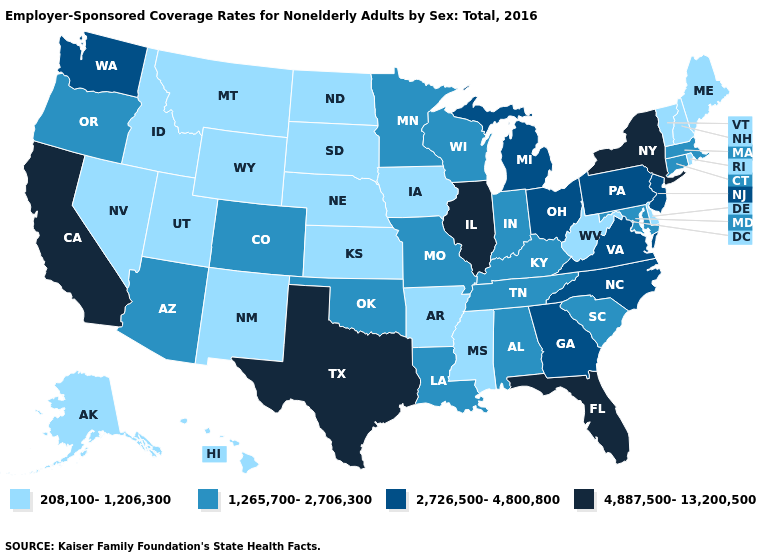What is the value of Colorado?
Quick response, please. 1,265,700-2,706,300. Name the states that have a value in the range 4,887,500-13,200,500?
Give a very brief answer. California, Florida, Illinois, New York, Texas. What is the value of Pennsylvania?
Answer briefly. 2,726,500-4,800,800. What is the value of Wyoming?
Concise answer only. 208,100-1,206,300. Name the states that have a value in the range 208,100-1,206,300?
Short answer required. Alaska, Arkansas, Delaware, Hawaii, Idaho, Iowa, Kansas, Maine, Mississippi, Montana, Nebraska, Nevada, New Hampshire, New Mexico, North Dakota, Rhode Island, South Dakota, Utah, Vermont, West Virginia, Wyoming. Which states hav the highest value in the MidWest?
Answer briefly. Illinois. What is the highest value in the West ?
Short answer required. 4,887,500-13,200,500. What is the value of New Hampshire?
Write a very short answer. 208,100-1,206,300. What is the value of Arizona?
Concise answer only. 1,265,700-2,706,300. What is the value of Maryland?
Keep it brief. 1,265,700-2,706,300. Does West Virginia have the lowest value in the South?
Give a very brief answer. Yes. Name the states that have a value in the range 208,100-1,206,300?
Short answer required. Alaska, Arkansas, Delaware, Hawaii, Idaho, Iowa, Kansas, Maine, Mississippi, Montana, Nebraska, Nevada, New Hampshire, New Mexico, North Dakota, Rhode Island, South Dakota, Utah, Vermont, West Virginia, Wyoming. Does Louisiana have the lowest value in the USA?
Be succinct. No. What is the lowest value in the USA?
Quick response, please. 208,100-1,206,300. What is the value of Kentucky?
Give a very brief answer. 1,265,700-2,706,300. 